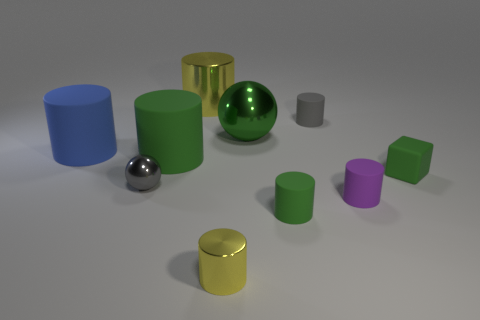Subtract all gray cylinders. How many cylinders are left? 6 Subtract all small yellow metal cylinders. How many cylinders are left? 6 Subtract all blue cylinders. Subtract all blue blocks. How many cylinders are left? 6 Subtract all blocks. How many objects are left? 9 Subtract all blue matte objects. Subtract all tiny metal cylinders. How many objects are left? 8 Add 7 big shiny cylinders. How many big shiny cylinders are left? 8 Add 9 big brown rubber spheres. How many big brown rubber spheres exist? 9 Subtract 0 purple cubes. How many objects are left? 10 